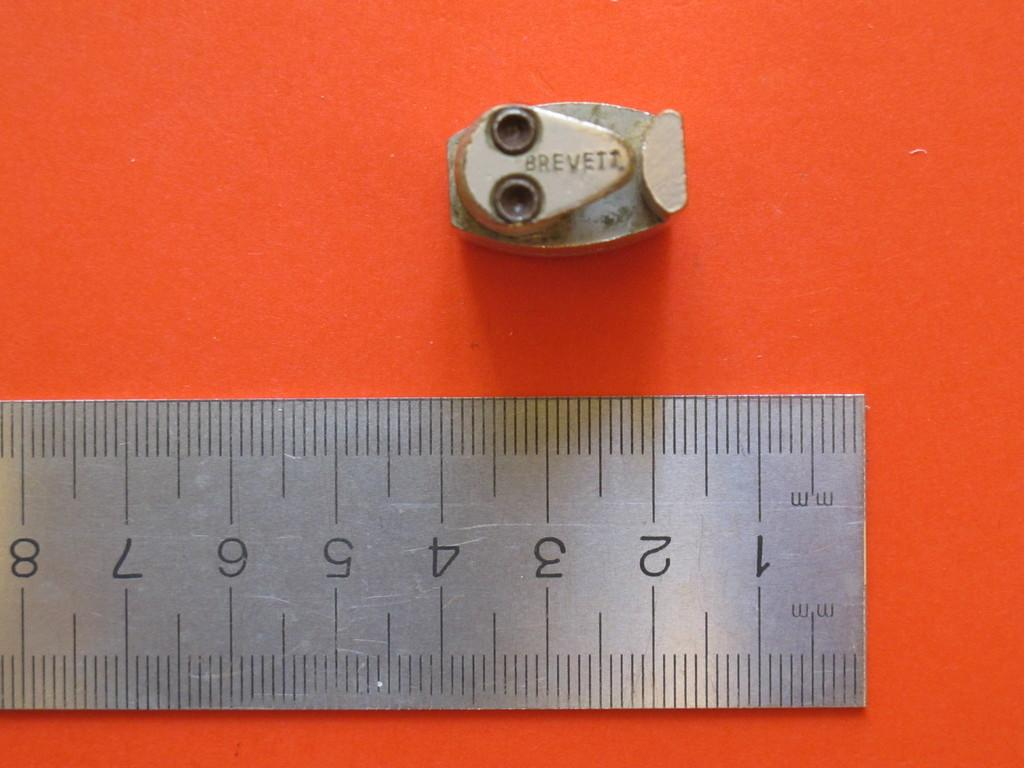Provide a one-sentence caption for the provided image. a piece of metal finding with BREVEIT ON IT and a ruler measuring mm. 